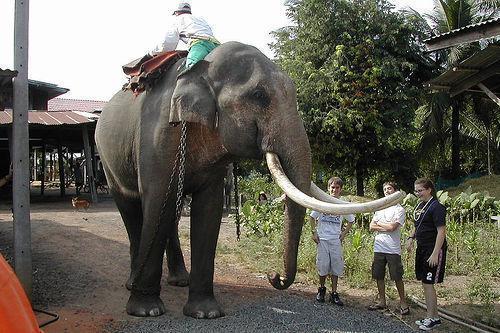How many people are in the picture?
Give a very brief answer. 4. How many people are riding the elephant?
Give a very brief answer. 1. How many people are standing next to the elephant?
Give a very brief answer. 3. 